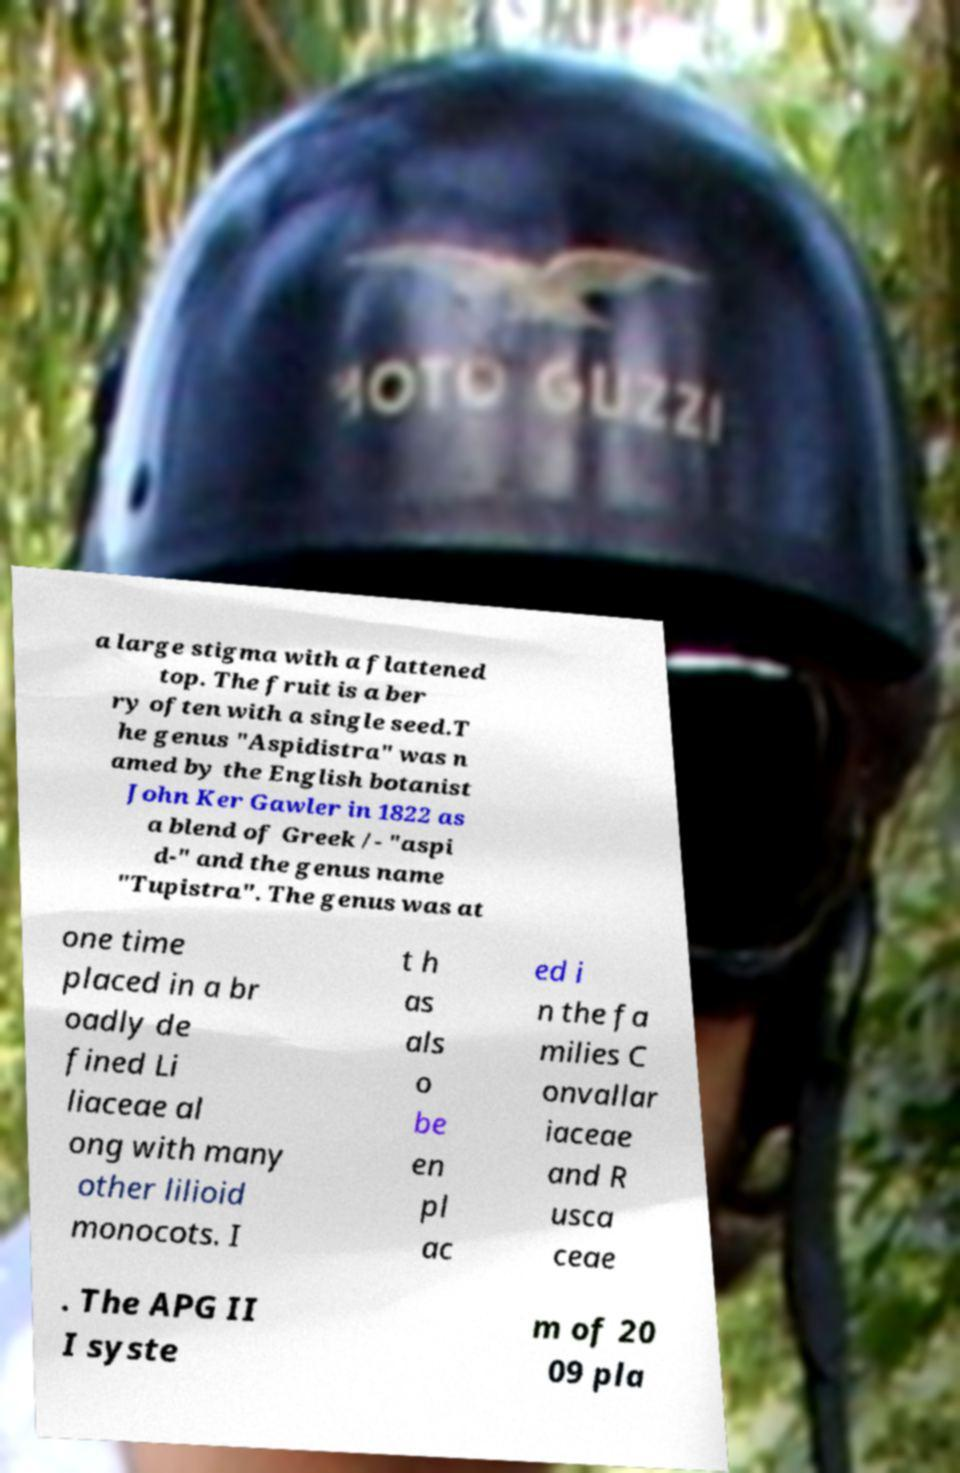What messages or text are displayed in this image? I need them in a readable, typed format. a large stigma with a flattened top. The fruit is a ber ry often with a single seed.T he genus "Aspidistra" was n amed by the English botanist John Ker Gawler in 1822 as a blend of Greek /- "aspi d-" and the genus name "Tupistra". The genus was at one time placed in a br oadly de fined Li liaceae al ong with many other lilioid monocots. I t h as als o be en pl ac ed i n the fa milies C onvallar iaceae and R usca ceae . The APG II I syste m of 20 09 pla 